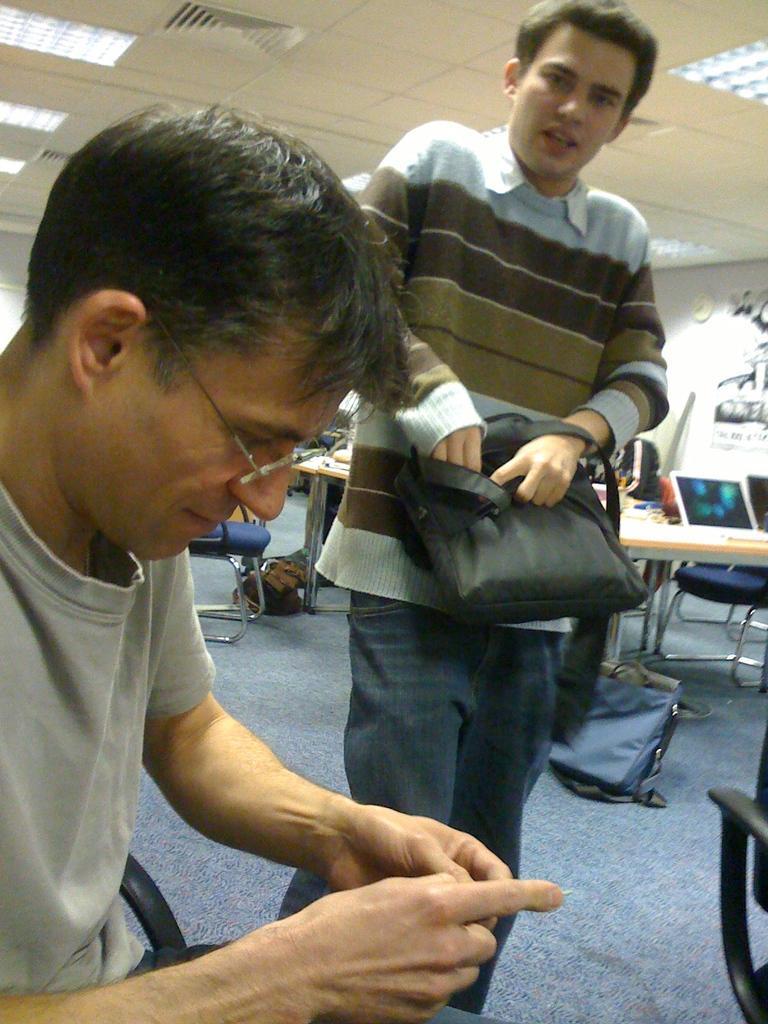Describe this image in one or two sentences. In this image in front there are two persons. Behind them there are tables, chairs, laptops and bags. In the background of the image there is a wall with the wall clock on it. At the top of the image there are ceiling lights. At the bottom of the image there is a mat. 